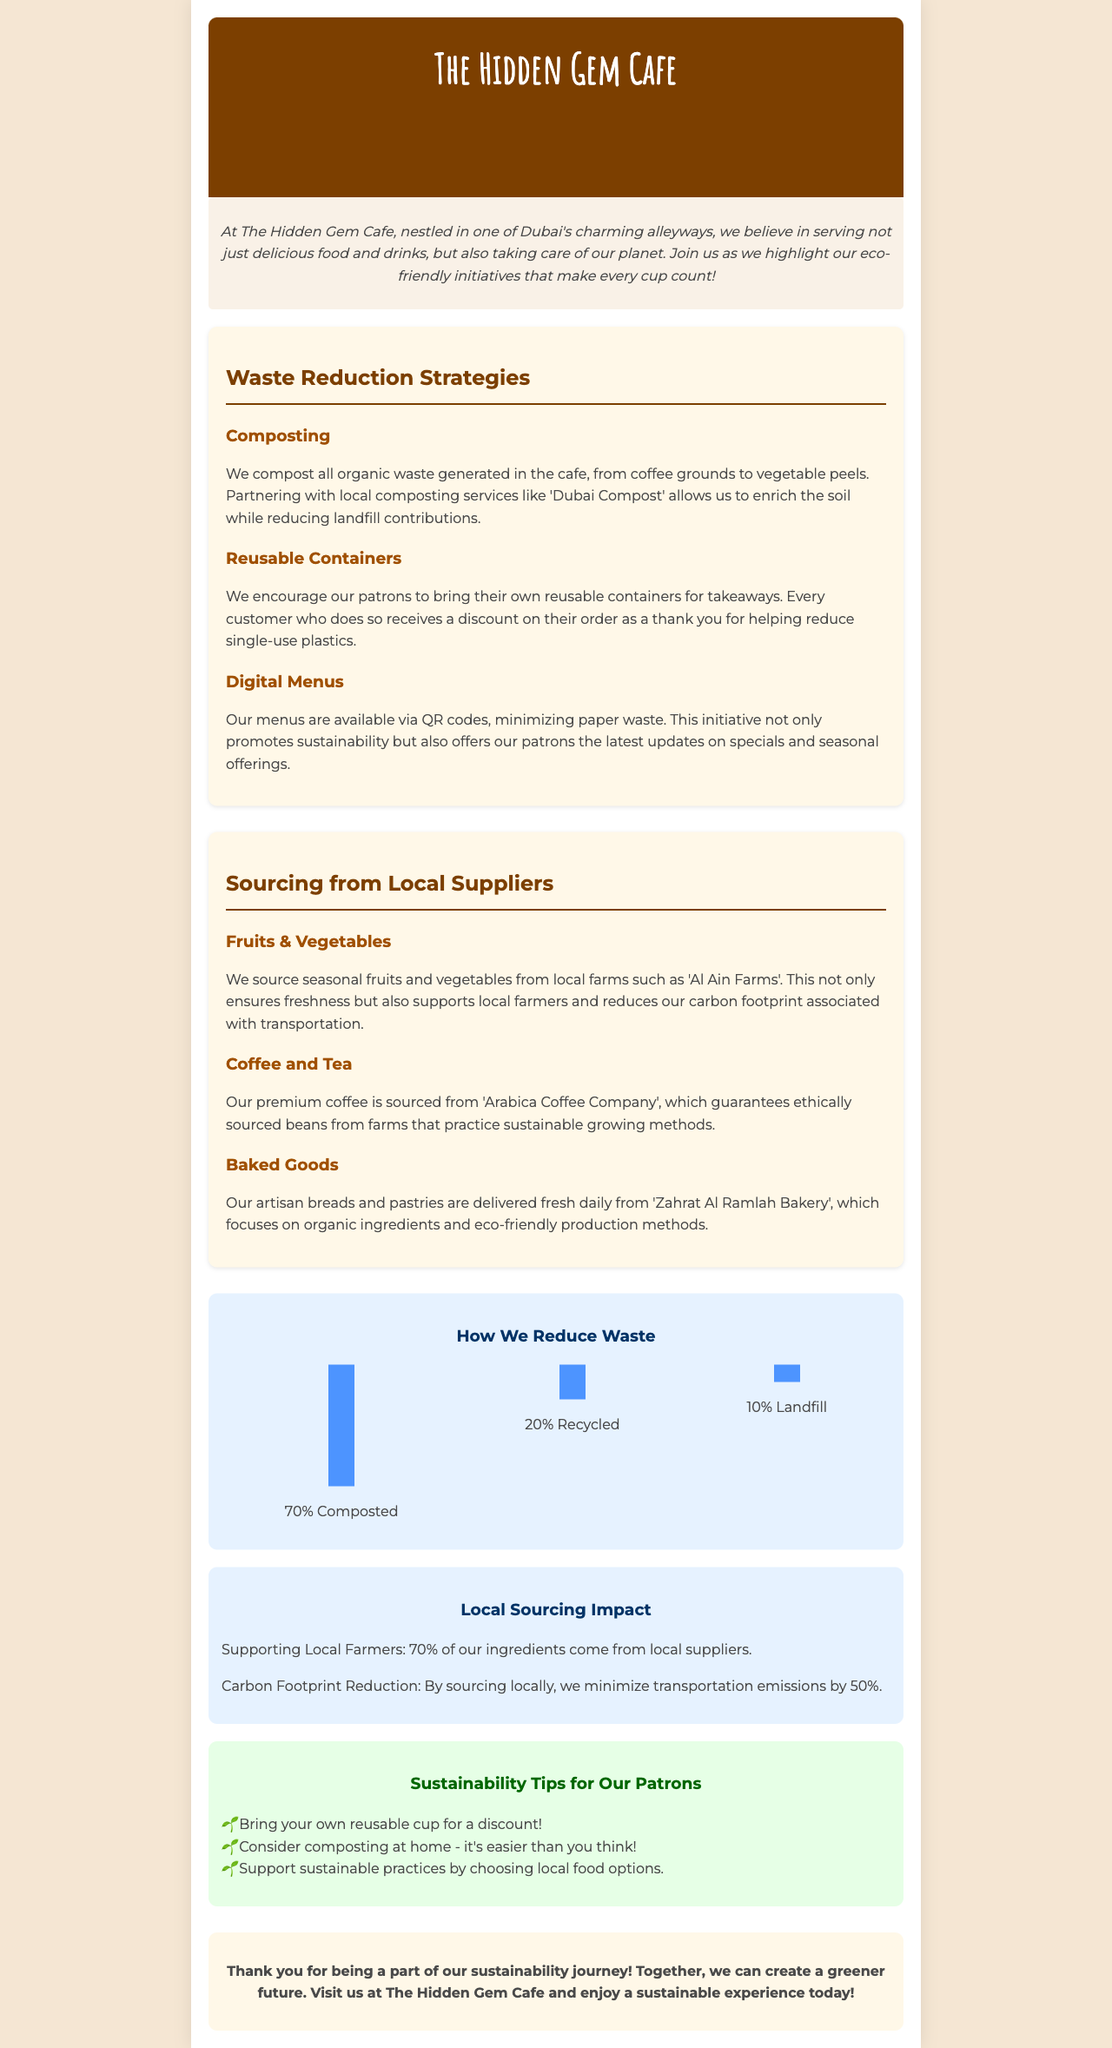What is the name of the cafe? The document provides the name of the cafe in the header.
Answer: The Hidden Gem Cafe What percentage of waste is composted? The infographic indicates the percentage of waste that is composted.
Answer: 70% Which local supplier provides seasonal fruits and vegetables? The document mentions the local supplier for fruits and vegetables in the sourcing section.
Answer: Al Ain Farms What type of discount is offered for using reusable containers? The cafe encourages bringing reusable containers by offering a discount, as stated in the document.
Answer: Discount What method is used to minimize paper waste? The section on waste reduction strategies describes an initiative that minimizes paper use.
Answer: Digital Menus How much does local sourcing reduce transportation emissions by? The infographic states the impact of local sourcing on transportation emissions.
Answer: 50% What is the primary goal of The Hidden Gem Cafe's sustainability initiatives? The introductory section of the document outlines the main aim of the cafe's eco-friendly initiatives.
Answer: Taking care of our planet Name one type of beverage sourced from sustainable methods. The document specifies the types of beverages sourced sustainably in the local suppliers section.
Answer: Coffee 